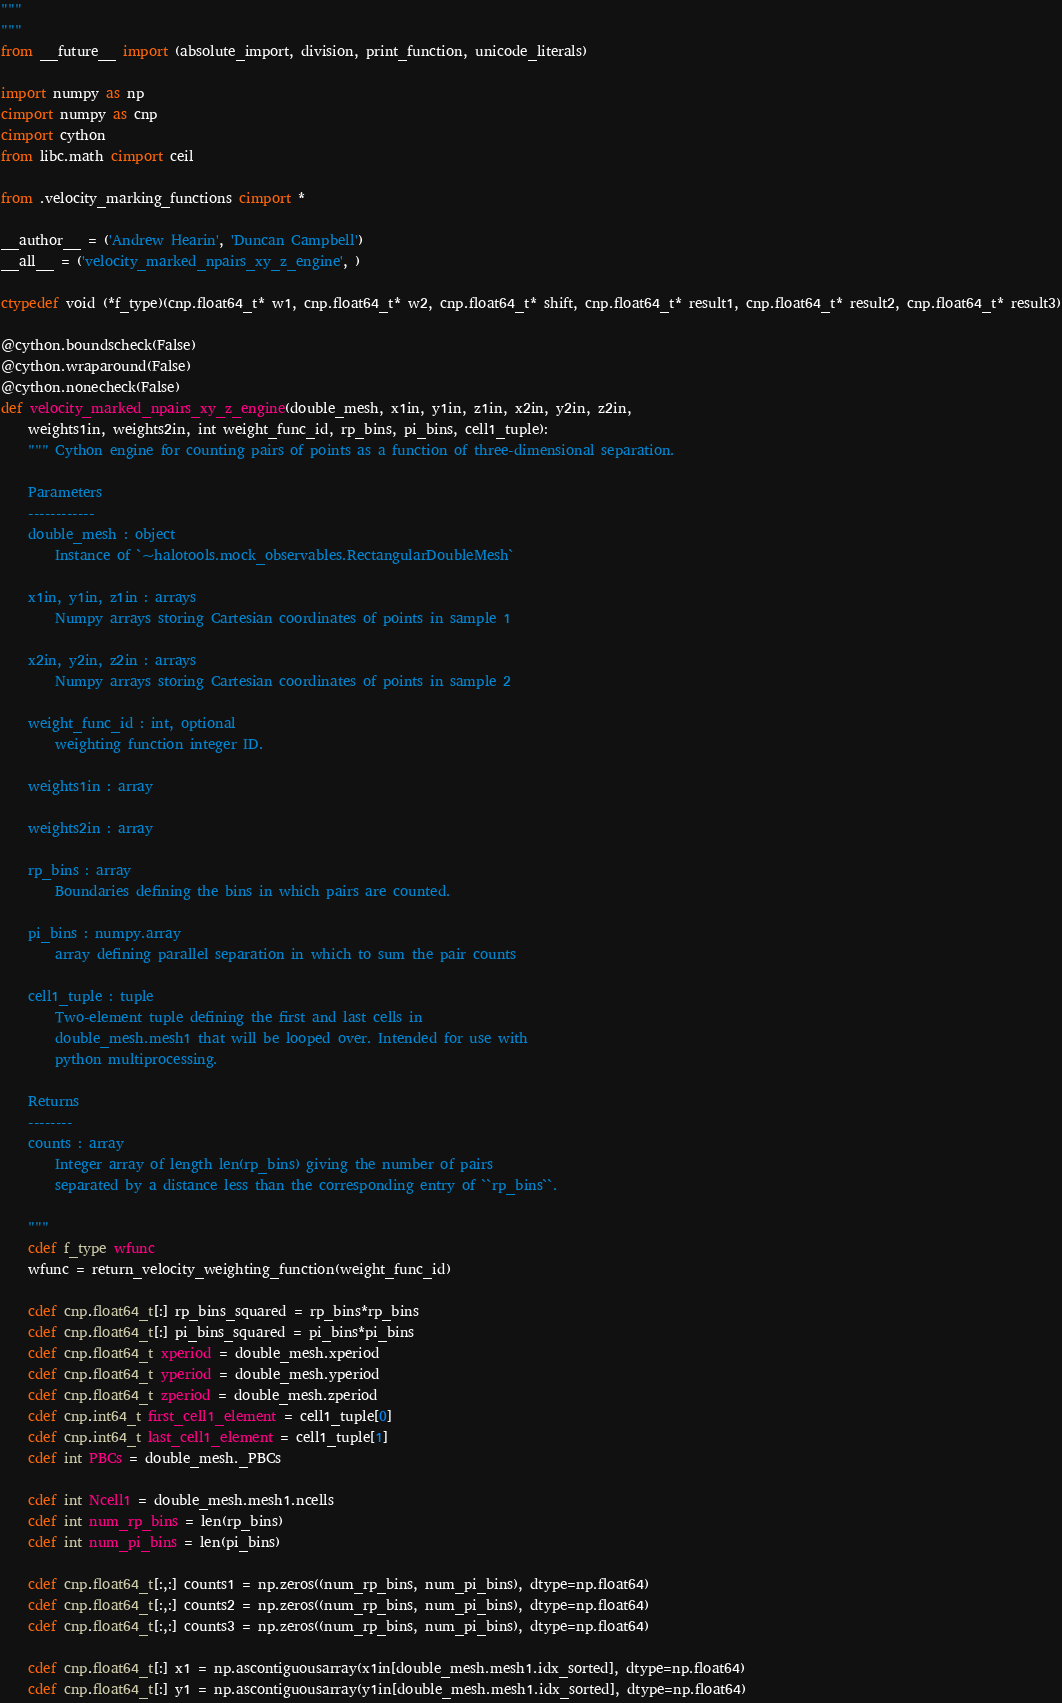Convert code to text. <code><loc_0><loc_0><loc_500><loc_500><_Cython_>"""
"""
from __future__ import (absolute_import, division, print_function, unicode_literals)

import numpy as np
cimport numpy as cnp
cimport cython 
from libc.math cimport ceil

from .velocity_marking_functions cimport *

__author__ = ('Andrew Hearin', 'Duncan Campbell')
__all__ = ('velocity_marked_npairs_xy_z_engine', )

ctypedef void (*f_type)(cnp.float64_t* w1, cnp.float64_t* w2, cnp.float64_t* shift, cnp.float64_t* result1, cnp.float64_t* result2, cnp.float64_t* result3)

@cython.boundscheck(False)
@cython.wraparound(False)
@cython.nonecheck(False)
def velocity_marked_npairs_xy_z_engine(double_mesh, x1in, y1in, z1in, x2in, y2in, z2in, 
    weights1in, weights2in, int weight_func_id, rp_bins, pi_bins, cell1_tuple):
    """ Cython engine for counting pairs of points as a function of three-dimensional separation. 

    Parameters 
    ------------
    double_mesh : object 
        Instance of `~halotools.mock_observables.RectangularDoubleMesh`

    x1in, y1in, z1in : arrays 
        Numpy arrays storing Cartesian coordinates of points in sample 1

    x2in, y2in, z2in : arrays 
        Numpy arrays storing Cartesian coordinates of points in sample 2

    weight_func_id : int, optional
        weighting function integer ID. 

    weights1in : array 

    weights2in : array 

    rp_bins : array
        Boundaries defining the bins in which pairs are counted.

    pi_bins : numpy.array
        array defining parallel separation in which to sum the pair counts

    cell1_tuple : tuple
        Two-element tuple defining the first and last cells in 
        double_mesh.mesh1 that will be looped over. Intended for use with 
        python multiprocessing. 

    Returns 
    --------
    counts : array 
        Integer array of length len(rp_bins) giving the number of pairs 
        separated by a distance less than the corresponding entry of ``rp_bins``. 

    """
    cdef f_type wfunc
    wfunc = return_velocity_weighting_function(weight_func_id)

    cdef cnp.float64_t[:] rp_bins_squared = rp_bins*rp_bins
    cdef cnp.float64_t[:] pi_bins_squared = pi_bins*pi_bins
    cdef cnp.float64_t xperiod = double_mesh.xperiod
    cdef cnp.float64_t yperiod = double_mesh.yperiod
    cdef cnp.float64_t zperiod = double_mesh.zperiod
    cdef cnp.int64_t first_cell1_element = cell1_tuple[0]
    cdef cnp.int64_t last_cell1_element = cell1_tuple[1]
    cdef int PBCs = double_mesh._PBCs

    cdef int Ncell1 = double_mesh.mesh1.ncells
    cdef int num_rp_bins = len(rp_bins)
    cdef int num_pi_bins = len(pi_bins)

    cdef cnp.float64_t[:,:] counts1 = np.zeros((num_rp_bins, num_pi_bins), dtype=np.float64)
    cdef cnp.float64_t[:,:] counts2 = np.zeros((num_rp_bins, num_pi_bins), dtype=np.float64)
    cdef cnp.float64_t[:,:] counts3 = np.zeros((num_rp_bins, num_pi_bins), dtype=np.float64)

    cdef cnp.float64_t[:] x1 = np.ascontiguousarray(x1in[double_mesh.mesh1.idx_sorted], dtype=np.float64)
    cdef cnp.float64_t[:] y1 = np.ascontiguousarray(y1in[double_mesh.mesh1.idx_sorted], dtype=np.float64)</code> 